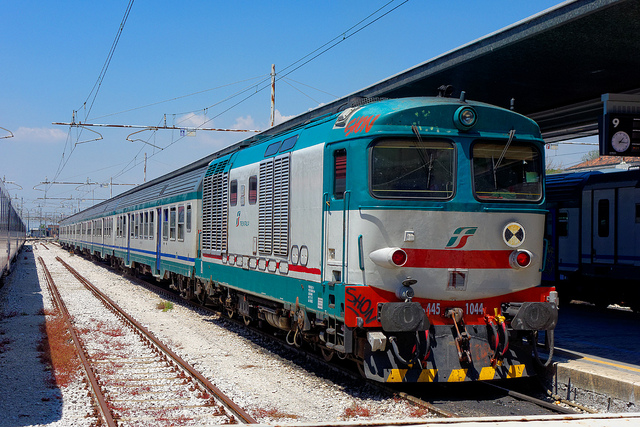Please transcribe the text information in this image. 445 SHON 9 